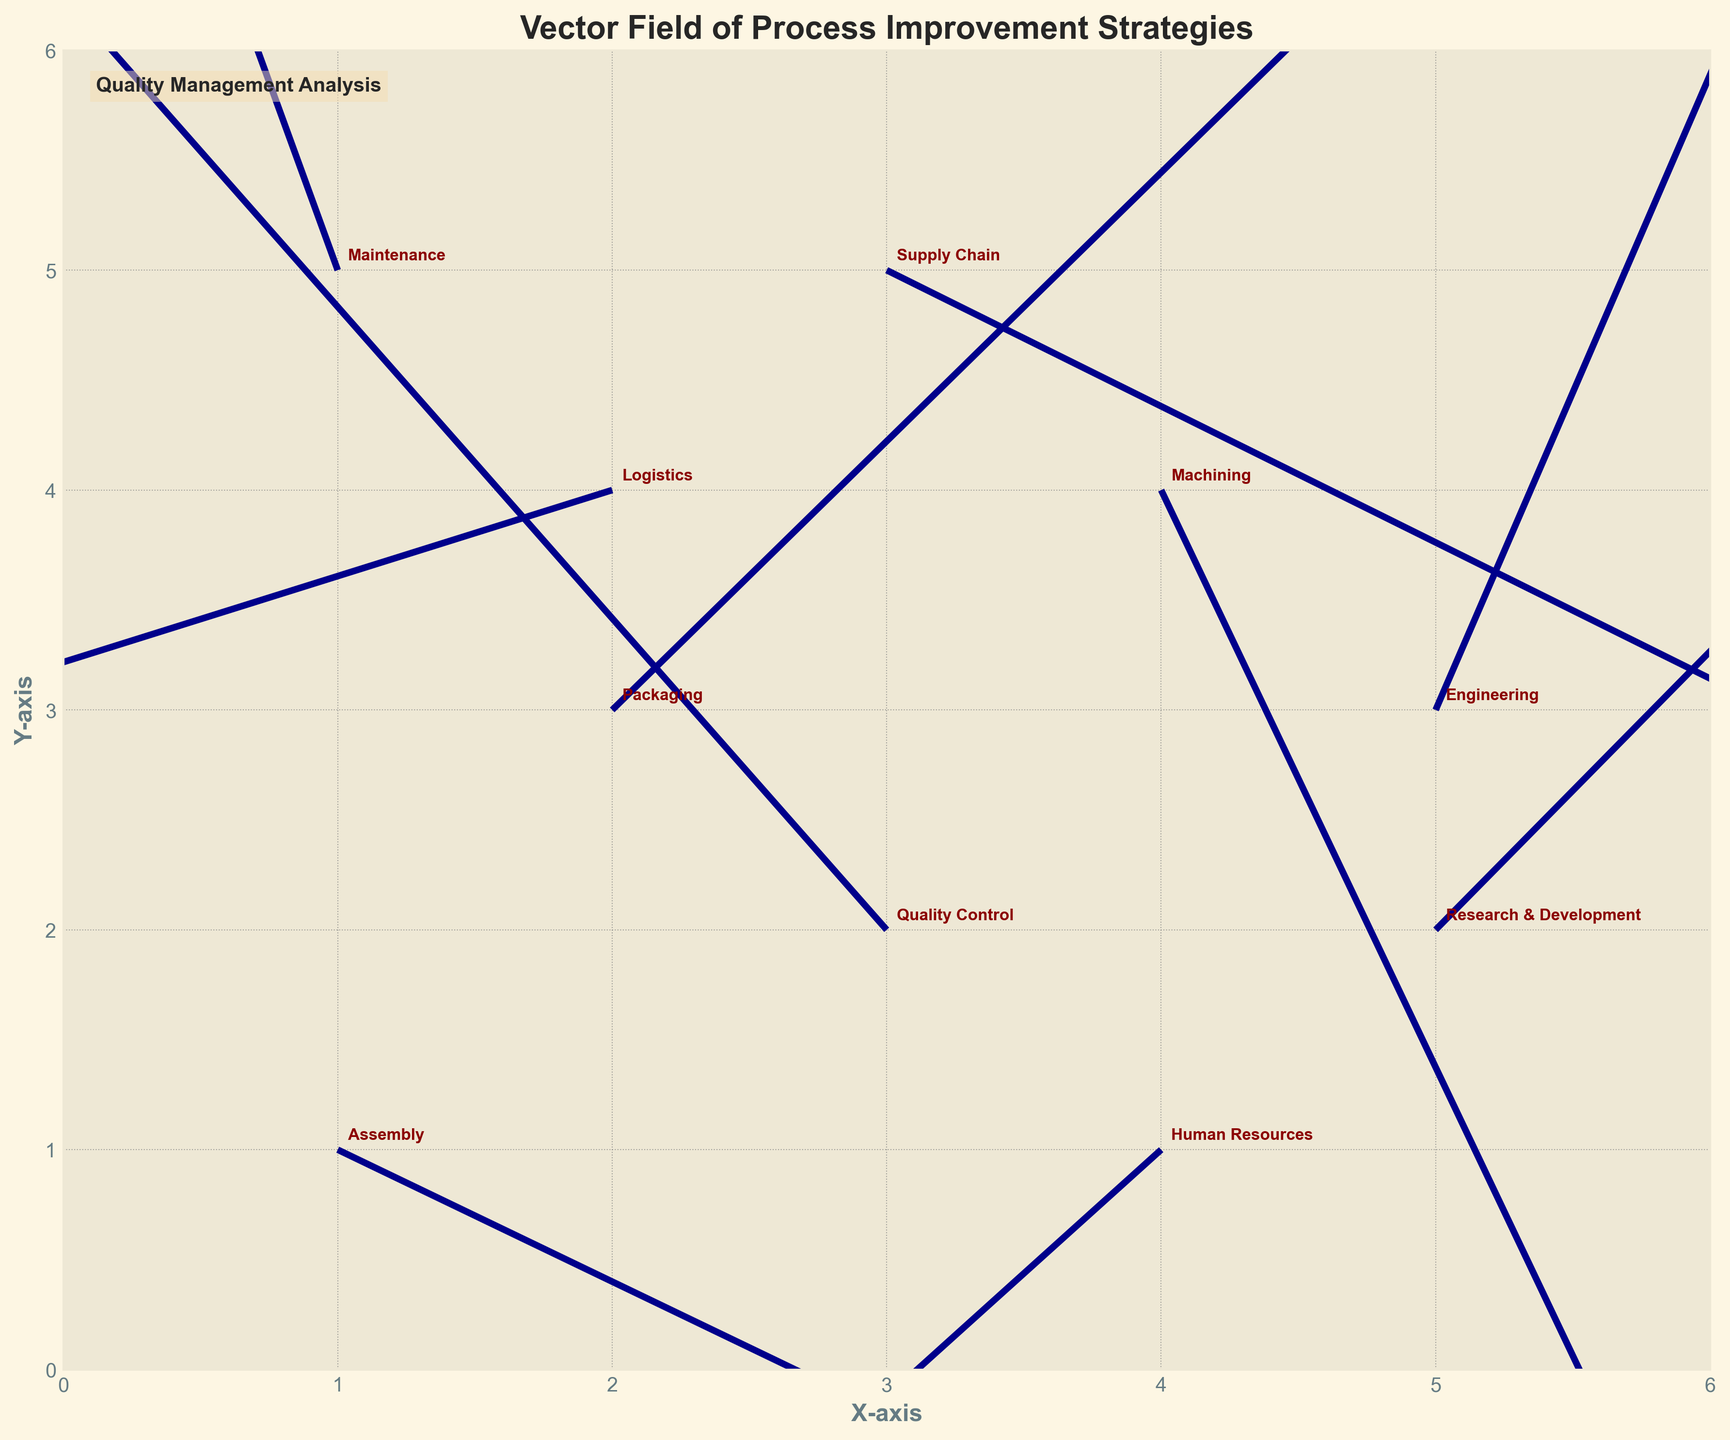What's the title of the figure? The title of the figure is typically located at the top center of the plot. Here, it's bold and easily noticeable.
Answer: Vector Field of Process Improvement Strategies What color are the vectors in the plot? The color of the vectors in the plot is consistently used. In this case, they are all colored dark blue.
Answer: Dark blue How many departments are represented in the plot? Each department is annotated near its corresponding quiver arrow. Counting these annotations helps identify the total number of departments.
Answer: 10 Which department has a vector pointing nearly straight up? By examining the direction of each vector, the one pointing nearly straight up is on the positive y-direction. Maintenance has this characteristic.
Answer: Maintenance What is annotated in the lower-left corner of the plot? There is custom text added in the lower-left corner for identification or annotation purposes.
Answer: Quality Management Analysis Which department has the longest vector? By comparing the lengths of all vectors, the one with the greatest magnitude can be identified. Research & Development stands out in length.
Answer: Research & Development Which department's vector points to the left and slightly up? By looking for vectors in the left and slightly upward direction, Quality Control can be identified.
Answer: Quality Control What are the x and y coordinates of the Human Resources department? The x and y coordinates are labeled alongside the department names. Human Resources is at coordinates (4, 1).
Answer: (4, 1) Compare the directions of Logistics and Supply Chain vectors. Which way do they point? By examining each vector's direction, Logistics points to the left and slightly down, while Supply Chain points to the right and slightly down.
Answer: Logistics: left and down, Supply Chain: right and down Which department's vector has the smallest vertical component? The vertical component (v) represents the vector's movement along the y-axis. Machining has the smallest vertical component (v = -2.1).
Answer: Machining 